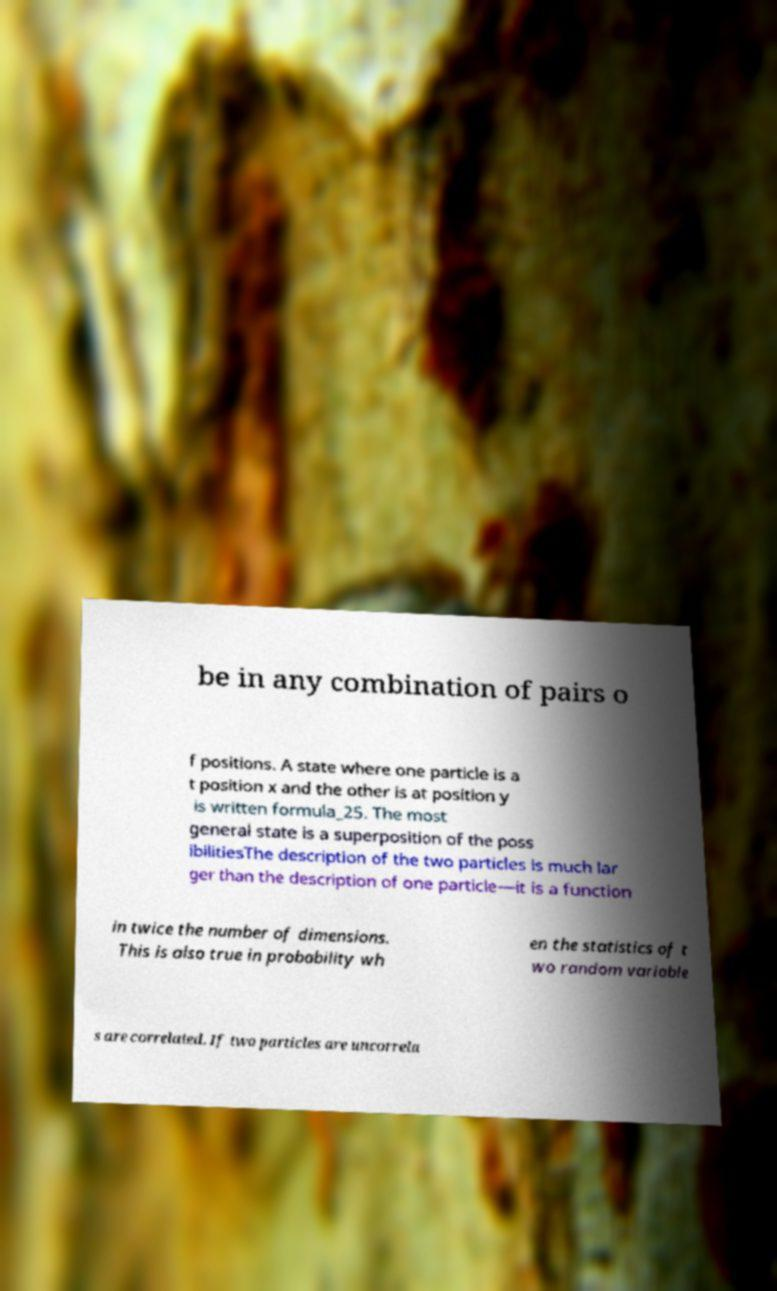For documentation purposes, I need the text within this image transcribed. Could you provide that? be in any combination of pairs o f positions. A state where one particle is a t position x and the other is at position y is written formula_25. The most general state is a superposition of the poss ibilitiesThe description of the two particles is much lar ger than the description of one particle—it is a function in twice the number of dimensions. This is also true in probability wh en the statistics of t wo random variable s are correlated. If two particles are uncorrela 